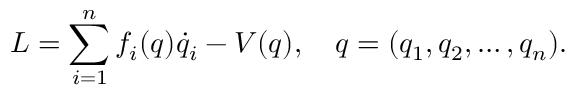<formula> <loc_0><loc_0><loc_500><loc_500>L = \sum _ { i = 1 } ^ { n } f _ { i } ( q ) \dot { q } _ { i } - V ( q ) , \quad q = ( q _ { 1 } , q _ { 2 } , \dots , q _ { n } ) { . }</formula> 